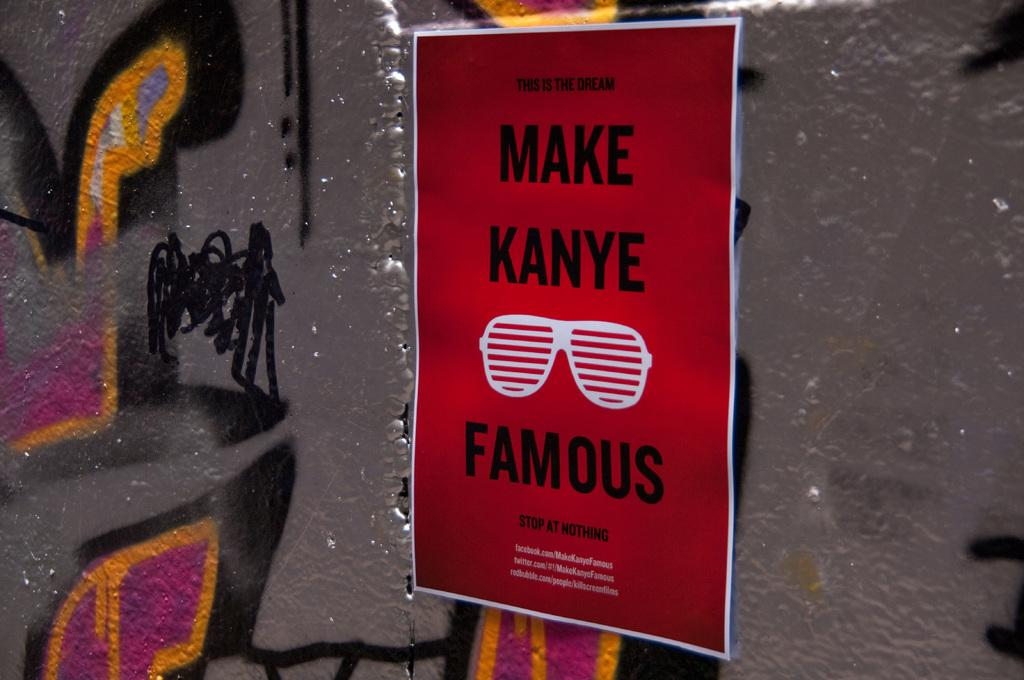<image>
Offer a succinct explanation of the picture presented. A poster on a graffiti backed wall says to Make Kanye Famous. 